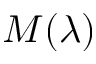Convert formula to latex. <formula><loc_0><loc_0><loc_500><loc_500>M ( \lambda )</formula> 